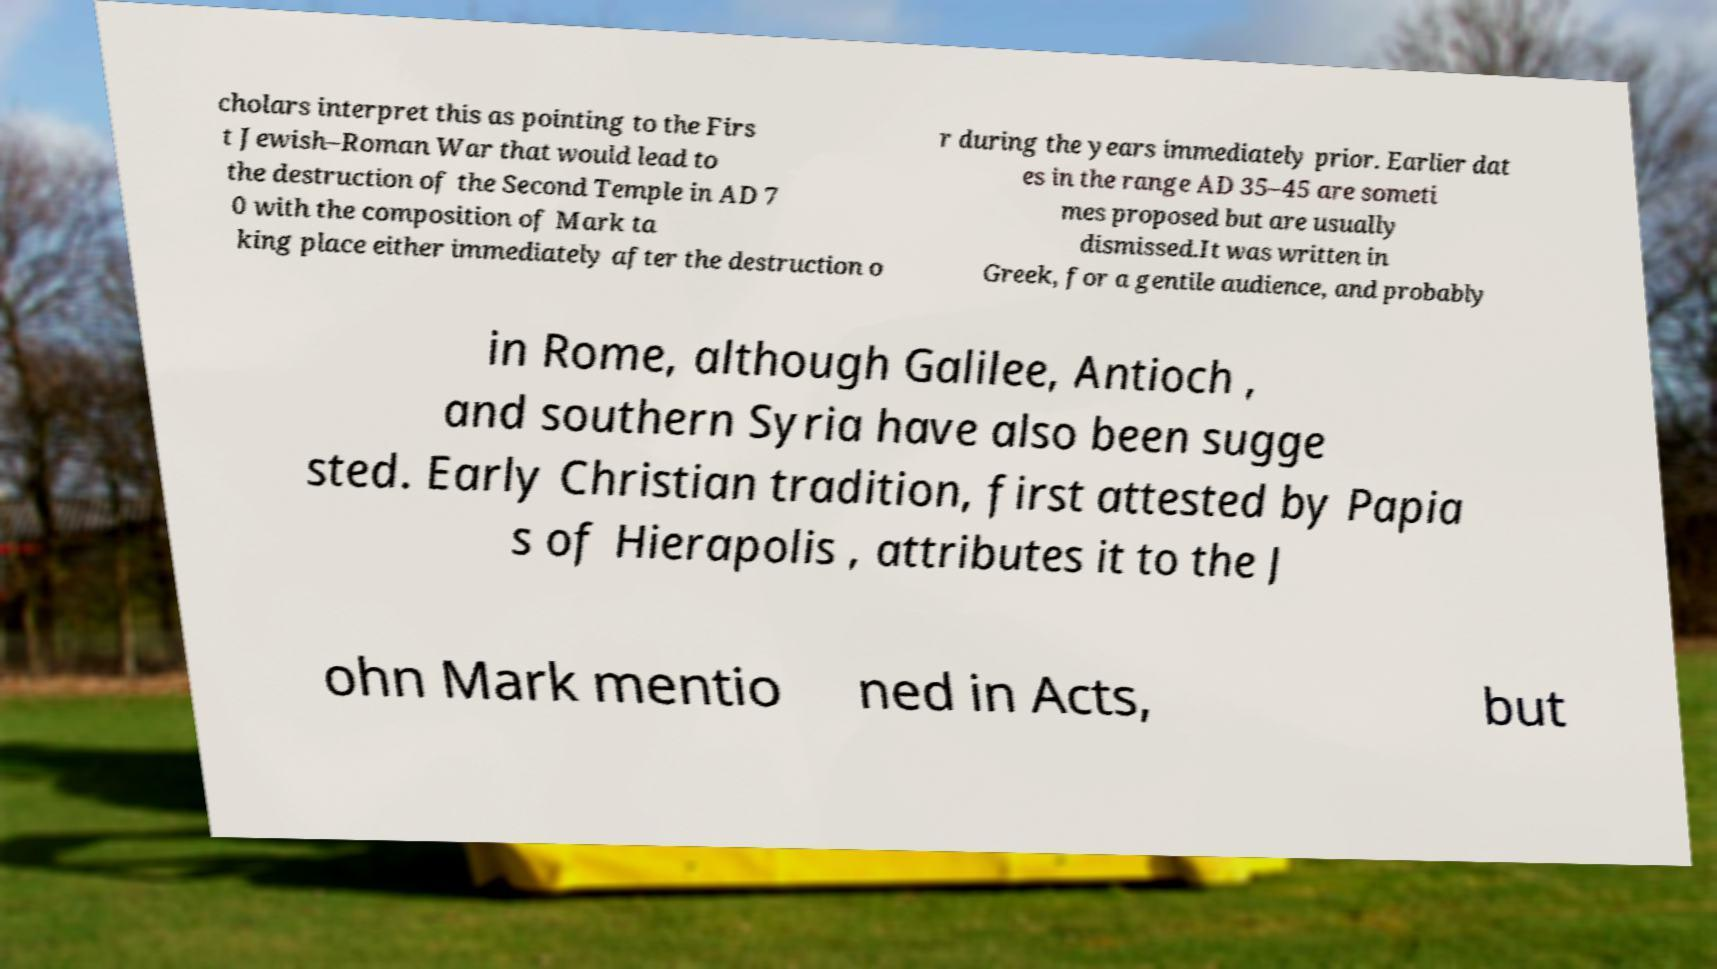Can you accurately transcribe the text from the provided image for me? cholars interpret this as pointing to the Firs t Jewish–Roman War that would lead to the destruction of the Second Temple in AD 7 0 with the composition of Mark ta king place either immediately after the destruction o r during the years immediately prior. Earlier dat es in the range AD 35–45 are someti mes proposed but are usually dismissed.It was written in Greek, for a gentile audience, and probably in Rome, although Galilee, Antioch , and southern Syria have also been sugge sted. Early Christian tradition, first attested by Papia s of Hierapolis , attributes it to the J ohn Mark mentio ned in Acts, but 